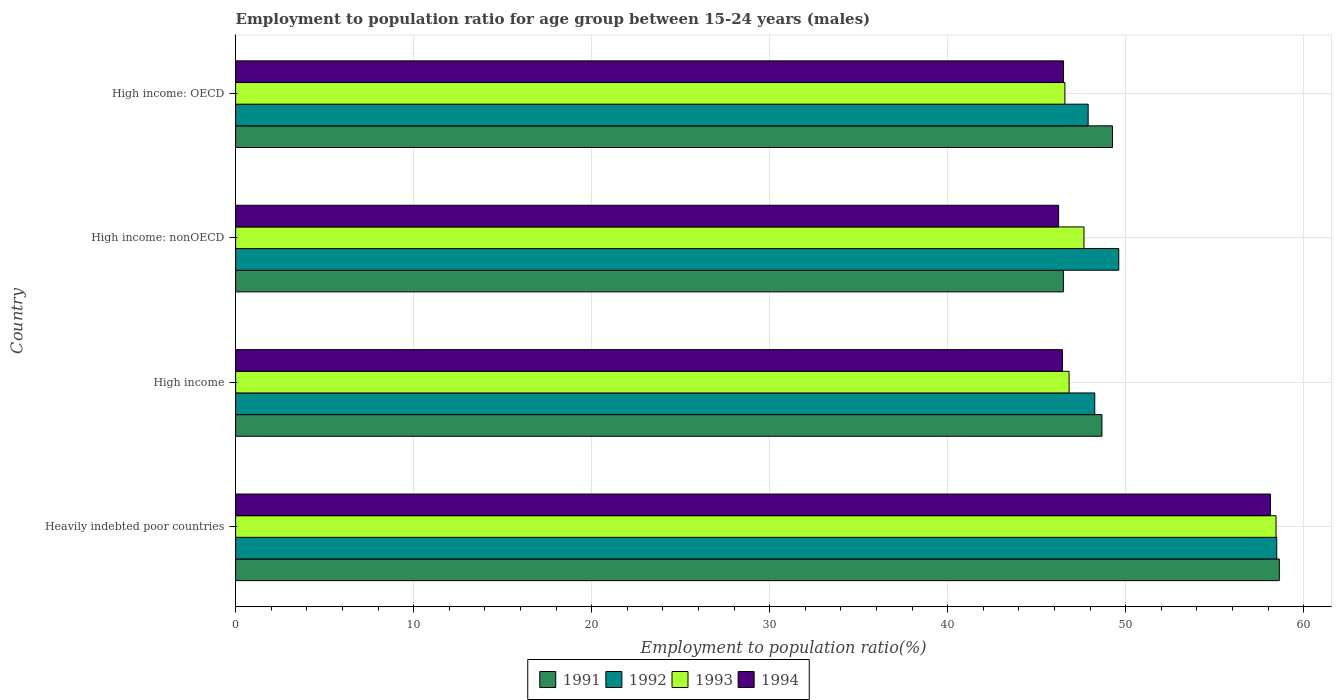How many groups of bars are there?
Keep it short and to the point. 4. Are the number of bars per tick equal to the number of legend labels?
Your answer should be very brief. Yes. Are the number of bars on each tick of the Y-axis equal?
Offer a very short reply. Yes. How many bars are there on the 2nd tick from the top?
Provide a short and direct response. 4. How many bars are there on the 2nd tick from the bottom?
Make the answer very short. 4. What is the label of the 2nd group of bars from the top?
Offer a very short reply. High income: nonOECD. In how many cases, is the number of bars for a given country not equal to the number of legend labels?
Provide a short and direct response. 0. What is the employment to population ratio in 1994 in High income: nonOECD?
Provide a succinct answer. 46.23. Across all countries, what is the maximum employment to population ratio in 1994?
Give a very brief answer. 58.13. Across all countries, what is the minimum employment to population ratio in 1994?
Your answer should be compact. 46.23. In which country was the employment to population ratio in 1994 maximum?
Your response must be concise. Heavily indebted poor countries. In which country was the employment to population ratio in 1992 minimum?
Keep it short and to the point. High income: OECD. What is the total employment to population ratio in 1991 in the graph?
Provide a short and direct response. 203.04. What is the difference between the employment to population ratio in 1992 in Heavily indebted poor countries and that in High income: nonOECD?
Your answer should be very brief. 8.87. What is the difference between the employment to population ratio in 1992 in Heavily indebted poor countries and the employment to population ratio in 1991 in High income: OECD?
Your response must be concise. 9.23. What is the average employment to population ratio in 1992 per country?
Give a very brief answer. 51.06. What is the difference between the employment to population ratio in 1994 and employment to population ratio in 1991 in High income?
Your answer should be compact. -2.22. What is the ratio of the employment to population ratio in 1994 in Heavily indebted poor countries to that in High income?
Your answer should be compact. 1.25. Is the employment to population ratio in 1992 in Heavily indebted poor countries less than that in High income: nonOECD?
Make the answer very short. No. Is the difference between the employment to population ratio in 1994 in Heavily indebted poor countries and High income: nonOECD greater than the difference between the employment to population ratio in 1991 in Heavily indebted poor countries and High income: nonOECD?
Keep it short and to the point. No. What is the difference between the highest and the second highest employment to population ratio in 1993?
Your answer should be very brief. 10.79. What is the difference between the highest and the lowest employment to population ratio in 1994?
Your answer should be compact. 11.9. In how many countries, is the employment to population ratio in 1992 greater than the average employment to population ratio in 1992 taken over all countries?
Ensure brevity in your answer.  1. Is it the case that in every country, the sum of the employment to population ratio in 1991 and employment to population ratio in 1993 is greater than the sum of employment to population ratio in 1994 and employment to population ratio in 1992?
Offer a terse response. No. What does the 4th bar from the bottom in High income: OECD represents?
Your answer should be very brief. 1994. How many bars are there?
Make the answer very short. 16. How many countries are there in the graph?
Offer a terse response. 4. What is the difference between two consecutive major ticks on the X-axis?
Give a very brief answer. 10. Are the values on the major ticks of X-axis written in scientific E-notation?
Offer a terse response. No. Does the graph contain any zero values?
Keep it short and to the point. No. Where does the legend appear in the graph?
Offer a terse response. Bottom center. How many legend labels are there?
Your answer should be compact. 4. What is the title of the graph?
Your answer should be compact. Employment to population ratio for age group between 15-24 years (males). Does "1964" appear as one of the legend labels in the graph?
Your response must be concise. No. What is the Employment to population ratio(%) in 1991 in Heavily indebted poor countries?
Your answer should be very brief. 58.63. What is the Employment to population ratio(%) of 1992 in Heavily indebted poor countries?
Provide a succinct answer. 58.48. What is the Employment to population ratio(%) of 1993 in Heavily indebted poor countries?
Provide a succinct answer. 58.44. What is the Employment to population ratio(%) of 1994 in Heavily indebted poor countries?
Your response must be concise. 58.13. What is the Employment to population ratio(%) in 1991 in High income?
Provide a succinct answer. 48.66. What is the Employment to population ratio(%) in 1992 in High income?
Offer a very short reply. 48.26. What is the Employment to population ratio(%) in 1993 in High income?
Your response must be concise. 46.82. What is the Employment to population ratio(%) in 1994 in High income?
Your answer should be very brief. 46.44. What is the Employment to population ratio(%) of 1991 in High income: nonOECD?
Make the answer very short. 46.5. What is the Employment to population ratio(%) of 1992 in High income: nonOECD?
Give a very brief answer. 49.61. What is the Employment to population ratio(%) in 1993 in High income: nonOECD?
Provide a succinct answer. 47.65. What is the Employment to population ratio(%) of 1994 in High income: nonOECD?
Make the answer very short. 46.23. What is the Employment to population ratio(%) in 1991 in High income: OECD?
Make the answer very short. 49.25. What is the Employment to population ratio(%) in 1992 in High income: OECD?
Provide a succinct answer. 47.89. What is the Employment to population ratio(%) in 1993 in High income: OECD?
Your answer should be compact. 46.58. What is the Employment to population ratio(%) in 1994 in High income: OECD?
Give a very brief answer. 46.5. Across all countries, what is the maximum Employment to population ratio(%) in 1991?
Keep it short and to the point. 58.63. Across all countries, what is the maximum Employment to population ratio(%) in 1992?
Provide a succinct answer. 58.48. Across all countries, what is the maximum Employment to population ratio(%) of 1993?
Your answer should be very brief. 58.44. Across all countries, what is the maximum Employment to population ratio(%) of 1994?
Your response must be concise. 58.13. Across all countries, what is the minimum Employment to population ratio(%) in 1991?
Your answer should be compact. 46.5. Across all countries, what is the minimum Employment to population ratio(%) in 1992?
Give a very brief answer. 47.89. Across all countries, what is the minimum Employment to population ratio(%) of 1993?
Provide a short and direct response. 46.58. Across all countries, what is the minimum Employment to population ratio(%) of 1994?
Your answer should be very brief. 46.23. What is the total Employment to population ratio(%) of 1991 in the graph?
Provide a short and direct response. 203.04. What is the total Employment to population ratio(%) in 1992 in the graph?
Offer a very short reply. 204.24. What is the total Employment to population ratio(%) of 1993 in the graph?
Provide a succinct answer. 199.5. What is the total Employment to population ratio(%) of 1994 in the graph?
Offer a very short reply. 197.3. What is the difference between the Employment to population ratio(%) of 1991 in Heavily indebted poor countries and that in High income?
Keep it short and to the point. 9.96. What is the difference between the Employment to population ratio(%) of 1992 in Heavily indebted poor countries and that in High income?
Your response must be concise. 10.22. What is the difference between the Employment to population ratio(%) of 1993 in Heavily indebted poor countries and that in High income?
Provide a succinct answer. 11.62. What is the difference between the Employment to population ratio(%) in 1994 in Heavily indebted poor countries and that in High income?
Provide a succinct answer. 11.69. What is the difference between the Employment to population ratio(%) of 1991 in Heavily indebted poor countries and that in High income: nonOECD?
Offer a terse response. 12.13. What is the difference between the Employment to population ratio(%) of 1992 in Heavily indebted poor countries and that in High income: nonOECD?
Offer a very short reply. 8.87. What is the difference between the Employment to population ratio(%) in 1993 in Heavily indebted poor countries and that in High income: nonOECD?
Offer a very short reply. 10.79. What is the difference between the Employment to population ratio(%) in 1994 in Heavily indebted poor countries and that in High income: nonOECD?
Offer a terse response. 11.9. What is the difference between the Employment to population ratio(%) of 1991 in Heavily indebted poor countries and that in High income: OECD?
Your answer should be compact. 9.37. What is the difference between the Employment to population ratio(%) of 1992 in Heavily indebted poor countries and that in High income: OECD?
Keep it short and to the point. 10.59. What is the difference between the Employment to population ratio(%) of 1993 in Heavily indebted poor countries and that in High income: OECD?
Provide a short and direct response. 11.86. What is the difference between the Employment to population ratio(%) of 1994 in Heavily indebted poor countries and that in High income: OECD?
Make the answer very short. 11.62. What is the difference between the Employment to population ratio(%) in 1991 in High income and that in High income: nonOECD?
Your answer should be very brief. 2.17. What is the difference between the Employment to population ratio(%) of 1992 in High income and that in High income: nonOECD?
Ensure brevity in your answer.  -1.35. What is the difference between the Employment to population ratio(%) in 1993 in High income and that in High income: nonOECD?
Offer a terse response. -0.84. What is the difference between the Employment to population ratio(%) of 1994 in High income and that in High income: nonOECD?
Provide a short and direct response. 0.21. What is the difference between the Employment to population ratio(%) of 1991 in High income and that in High income: OECD?
Offer a very short reply. -0.59. What is the difference between the Employment to population ratio(%) in 1992 in High income and that in High income: OECD?
Your response must be concise. 0.37. What is the difference between the Employment to population ratio(%) of 1993 in High income and that in High income: OECD?
Ensure brevity in your answer.  0.23. What is the difference between the Employment to population ratio(%) in 1994 in High income and that in High income: OECD?
Your answer should be very brief. -0.06. What is the difference between the Employment to population ratio(%) in 1991 in High income: nonOECD and that in High income: OECD?
Keep it short and to the point. -2.76. What is the difference between the Employment to population ratio(%) in 1992 in High income: nonOECD and that in High income: OECD?
Provide a short and direct response. 1.72. What is the difference between the Employment to population ratio(%) of 1993 in High income: nonOECD and that in High income: OECD?
Make the answer very short. 1.07. What is the difference between the Employment to population ratio(%) in 1994 in High income: nonOECD and that in High income: OECD?
Your response must be concise. -0.27. What is the difference between the Employment to population ratio(%) in 1991 in Heavily indebted poor countries and the Employment to population ratio(%) in 1992 in High income?
Make the answer very short. 10.37. What is the difference between the Employment to population ratio(%) of 1991 in Heavily indebted poor countries and the Employment to population ratio(%) of 1993 in High income?
Ensure brevity in your answer.  11.81. What is the difference between the Employment to population ratio(%) of 1991 in Heavily indebted poor countries and the Employment to population ratio(%) of 1994 in High income?
Your answer should be compact. 12.18. What is the difference between the Employment to population ratio(%) in 1992 in Heavily indebted poor countries and the Employment to population ratio(%) in 1993 in High income?
Make the answer very short. 11.66. What is the difference between the Employment to population ratio(%) in 1992 in Heavily indebted poor countries and the Employment to population ratio(%) in 1994 in High income?
Your answer should be very brief. 12.04. What is the difference between the Employment to population ratio(%) in 1993 in Heavily indebted poor countries and the Employment to population ratio(%) in 1994 in High income?
Offer a very short reply. 12. What is the difference between the Employment to population ratio(%) of 1991 in Heavily indebted poor countries and the Employment to population ratio(%) of 1992 in High income: nonOECD?
Your response must be concise. 9.02. What is the difference between the Employment to population ratio(%) of 1991 in Heavily indebted poor countries and the Employment to population ratio(%) of 1993 in High income: nonOECD?
Provide a short and direct response. 10.97. What is the difference between the Employment to population ratio(%) of 1991 in Heavily indebted poor countries and the Employment to population ratio(%) of 1994 in High income: nonOECD?
Your answer should be compact. 12.4. What is the difference between the Employment to population ratio(%) in 1992 in Heavily indebted poor countries and the Employment to population ratio(%) in 1993 in High income: nonOECD?
Make the answer very short. 10.83. What is the difference between the Employment to population ratio(%) in 1992 in Heavily indebted poor countries and the Employment to population ratio(%) in 1994 in High income: nonOECD?
Offer a very short reply. 12.25. What is the difference between the Employment to population ratio(%) in 1993 in Heavily indebted poor countries and the Employment to population ratio(%) in 1994 in High income: nonOECD?
Provide a short and direct response. 12.21. What is the difference between the Employment to population ratio(%) in 1991 in Heavily indebted poor countries and the Employment to population ratio(%) in 1992 in High income: OECD?
Make the answer very short. 10.74. What is the difference between the Employment to population ratio(%) in 1991 in Heavily indebted poor countries and the Employment to population ratio(%) in 1993 in High income: OECD?
Your answer should be very brief. 12.04. What is the difference between the Employment to population ratio(%) of 1991 in Heavily indebted poor countries and the Employment to population ratio(%) of 1994 in High income: OECD?
Provide a succinct answer. 12.12. What is the difference between the Employment to population ratio(%) in 1992 in Heavily indebted poor countries and the Employment to population ratio(%) in 1993 in High income: OECD?
Provide a short and direct response. 11.9. What is the difference between the Employment to population ratio(%) of 1992 in Heavily indebted poor countries and the Employment to population ratio(%) of 1994 in High income: OECD?
Your response must be concise. 11.98. What is the difference between the Employment to population ratio(%) of 1993 in Heavily indebted poor countries and the Employment to population ratio(%) of 1994 in High income: OECD?
Keep it short and to the point. 11.94. What is the difference between the Employment to population ratio(%) in 1991 in High income and the Employment to population ratio(%) in 1992 in High income: nonOECD?
Your answer should be compact. -0.94. What is the difference between the Employment to population ratio(%) of 1991 in High income and the Employment to population ratio(%) of 1993 in High income: nonOECD?
Make the answer very short. 1.01. What is the difference between the Employment to population ratio(%) in 1991 in High income and the Employment to population ratio(%) in 1994 in High income: nonOECD?
Provide a succinct answer. 2.43. What is the difference between the Employment to population ratio(%) of 1992 in High income and the Employment to population ratio(%) of 1993 in High income: nonOECD?
Provide a short and direct response. 0.61. What is the difference between the Employment to population ratio(%) of 1992 in High income and the Employment to population ratio(%) of 1994 in High income: nonOECD?
Ensure brevity in your answer.  2.03. What is the difference between the Employment to population ratio(%) in 1993 in High income and the Employment to population ratio(%) in 1994 in High income: nonOECD?
Your answer should be compact. 0.59. What is the difference between the Employment to population ratio(%) in 1991 in High income and the Employment to population ratio(%) in 1992 in High income: OECD?
Keep it short and to the point. 0.78. What is the difference between the Employment to population ratio(%) in 1991 in High income and the Employment to population ratio(%) in 1993 in High income: OECD?
Provide a short and direct response. 2.08. What is the difference between the Employment to population ratio(%) in 1991 in High income and the Employment to population ratio(%) in 1994 in High income: OECD?
Provide a succinct answer. 2.16. What is the difference between the Employment to population ratio(%) in 1992 in High income and the Employment to population ratio(%) in 1993 in High income: OECD?
Make the answer very short. 1.68. What is the difference between the Employment to population ratio(%) in 1992 in High income and the Employment to population ratio(%) in 1994 in High income: OECD?
Your answer should be compact. 1.76. What is the difference between the Employment to population ratio(%) in 1993 in High income and the Employment to population ratio(%) in 1994 in High income: OECD?
Provide a succinct answer. 0.31. What is the difference between the Employment to population ratio(%) of 1991 in High income: nonOECD and the Employment to population ratio(%) of 1992 in High income: OECD?
Your response must be concise. -1.39. What is the difference between the Employment to population ratio(%) of 1991 in High income: nonOECD and the Employment to population ratio(%) of 1993 in High income: OECD?
Make the answer very short. -0.09. What is the difference between the Employment to population ratio(%) of 1991 in High income: nonOECD and the Employment to population ratio(%) of 1994 in High income: OECD?
Your answer should be very brief. -0.01. What is the difference between the Employment to population ratio(%) in 1992 in High income: nonOECD and the Employment to population ratio(%) in 1993 in High income: OECD?
Provide a short and direct response. 3.03. What is the difference between the Employment to population ratio(%) of 1992 in High income: nonOECD and the Employment to population ratio(%) of 1994 in High income: OECD?
Your answer should be very brief. 3.1. What is the difference between the Employment to population ratio(%) in 1993 in High income: nonOECD and the Employment to population ratio(%) in 1994 in High income: OECD?
Offer a very short reply. 1.15. What is the average Employment to population ratio(%) of 1991 per country?
Keep it short and to the point. 50.76. What is the average Employment to population ratio(%) in 1992 per country?
Offer a very short reply. 51.06. What is the average Employment to population ratio(%) in 1993 per country?
Your response must be concise. 49.87. What is the average Employment to population ratio(%) of 1994 per country?
Make the answer very short. 49.33. What is the difference between the Employment to population ratio(%) in 1991 and Employment to population ratio(%) in 1992 in Heavily indebted poor countries?
Your response must be concise. 0.14. What is the difference between the Employment to population ratio(%) in 1991 and Employment to population ratio(%) in 1993 in Heavily indebted poor countries?
Make the answer very short. 0.18. What is the difference between the Employment to population ratio(%) in 1991 and Employment to population ratio(%) in 1994 in Heavily indebted poor countries?
Offer a very short reply. 0.5. What is the difference between the Employment to population ratio(%) in 1992 and Employment to population ratio(%) in 1993 in Heavily indebted poor countries?
Keep it short and to the point. 0.04. What is the difference between the Employment to population ratio(%) in 1992 and Employment to population ratio(%) in 1994 in Heavily indebted poor countries?
Keep it short and to the point. 0.35. What is the difference between the Employment to population ratio(%) in 1993 and Employment to population ratio(%) in 1994 in Heavily indebted poor countries?
Your response must be concise. 0.31. What is the difference between the Employment to population ratio(%) of 1991 and Employment to population ratio(%) of 1992 in High income?
Your answer should be compact. 0.4. What is the difference between the Employment to population ratio(%) in 1991 and Employment to population ratio(%) in 1993 in High income?
Make the answer very short. 1.85. What is the difference between the Employment to population ratio(%) in 1991 and Employment to population ratio(%) in 1994 in High income?
Your response must be concise. 2.22. What is the difference between the Employment to population ratio(%) of 1992 and Employment to population ratio(%) of 1993 in High income?
Make the answer very short. 1.44. What is the difference between the Employment to population ratio(%) of 1992 and Employment to population ratio(%) of 1994 in High income?
Ensure brevity in your answer.  1.82. What is the difference between the Employment to population ratio(%) in 1993 and Employment to population ratio(%) in 1994 in High income?
Your answer should be very brief. 0.38. What is the difference between the Employment to population ratio(%) of 1991 and Employment to population ratio(%) of 1992 in High income: nonOECD?
Your answer should be very brief. -3.11. What is the difference between the Employment to population ratio(%) of 1991 and Employment to population ratio(%) of 1993 in High income: nonOECD?
Ensure brevity in your answer.  -1.16. What is the difference between the Employment to population ratio(%) in 1991 and Employment to population ratio(%) in 1994 in High income: nonOECD?
Provide a succinct answer. 0.27. What is the difference between the Employment to population ratio(%) in 1992 and Employment to population ratio(%) in 1993 in High income: nonOECD?
Give a very brief answer. 1.95. What is the difference between the Employment to population ratio(%) of 1992 and Employment to population ratio(%) of 1994 in High income: nonOECD?
Give a very brief answer. 3.38. What is the difference between the Employment to population ratio(%) of 1993 and Employment to population ratio(%) of 1994 in High income: nonOECD?
Offer a terse response. 1.42. What is the difference between the Employment to population ratio(%) in 1991 and Employment to population ratio(%) in 1992 in High income: OECD?
Offer a very short reply. 1.37. What is the difference between the Employment to population ratio(%) in 1991 and Employment to population ratio(%) in 1993 in High income: OECD?
Offer a terse response. 2.67. What is the difference between the Employment to population ratio(%) of 1991 and Employment to population ratio(%) of 1994 in High income: OECD?
Provide a succinct answer. 2.75. What is the difference between the Employment to population ratio(%) of 1992 and Employment to population ratio(%) of 1993 in High income: OECD?
Provide a short and direct response. 1.31. What is the difference between the Employment to population ratio(%) in 1992 and Employment to population ratio(%) in 1994 in High income: OECD?
Your answer should be very brief. 1.38. What is the difference between the Employment to population ratio(%) of 1993 and Employment to population ratio(%) of 1994 in High income: OECD?
Provide a succinct answer. 0.08. What is the ratio of the Employment to population ratio(%) of 1991 in Heavily indebted poor countries to that in High income?
Provide a short and direct response. 1.2. What is the ratio of the Employment to population ratio(%) of 1992 in Heavily indebted poor countries to that in High income?
Your response must be concise. 1.21. What is the ratio of the Employment to population ratio(%) of 1993 in Heavily indebted poor countries to that in High income?
Make the answer very short. 1.25. What is the ratio of the Employment to population ratio(%) in 1994 in Heavily indebted poor countries to that in High income?
Offer a very short reply. 1.25. What is the ratio of the Employment to population ratio(%) in 1991 in Heavily indebted poor countries to that in High income: nonOECD?
Your answer should be compact. 1.26. What is the ratio of the Employment to population ratio(%) in 1992 in Heavily indebted poor countries to that in High income: nonOECD?
Offer a terse response. 1.18. What is the ratio of the Employment to population ratio(%) in 1993 in Heavily indebted poor countries to that in High income: nonOECD?
Offer a very short reply. 1.23. What is the ratio of the Employment to population ratio(%) of 1994 in Heavily indebted poor countries to that in High income: nonOECD?
Your response must be concise. 1.26. What is the ratio of the Employment to population ratio(%) of 1991 in Heavily indebted poor countries to that in High income: OECD?
Make the answer very short. 1.19. What is the ratio of the Employment to population ratio(%) in 1992 in Heavily indebted poor countries to that in High income: OECD?
Ensure brevity in your answer.  1.22. What is the ratio of the Employment to population ratio(%) of 1993 in Heavily indebted poor countries to that in High income: OECD?
Your answer should be compact. 1.25. What is the ratio of the Employment to population ratio(%) of 1991 in High income to that in High income: nonOECD?
Offer a terse response. 1.05. What is the ratio of the Employment to population ratio(%) of 1992 in High income to that in High income: nonOECD?
Your answer should be very brief. 0.97. What is the ratio of the Employment to population ratio(%) in 1993 in High income to that in High income: nonOECD?
Keep it short and to the point. 0.98. What is the ratio of the Employment to population ratio(%) of 1992 in High income to that in High income: OECD?
Your response must be concise. 1.01. What is the ratio of the Employment to population ratio(%) of 1994 in High income to that in High income: OECD?
Offer a very short reply. 1. What is the ratio of the Employment to population ratio(%) of 1991 in High income: nonOECD to that in High income: OECD?
Your response must be concise. 0.94. What is the ratio of the Employment to population ratio(%) of 1992 in High income: nonOECD to that in High income: OECD?
Make the answer very short. 1.04. What is the difference between the highest and the second highest Employment to population ratio(%) of 1991?
Your response must be concise. 9.37. What is the difference between the highest and the second highest Employment to population ratio(%) of 1992?
Ensure brevity in your answer.  8.87. What is the difference between the highest and the second highest Employment to population ratio(%) of 1993?
Offer a terse response. 10.79. What is the difference between the highest and the second highest Employment to population ratio(%) in 1994?
Ensure brevity in your answer.  11.62. What is the difference between the highest and the lowest Employment to population ratio(%) in 1991?
Ensure brevity in your answer.  12.13. What is the difference between the highest and the lowest Employment to population ratio(%) of 1992?
Provide a short and direct response. 10.59. What is the difference between the highest and the lowest Employment to population ratio(%) in 1993?
Your answer should be compact. 11.86. What is the difference between the highest and the lowest Employment to population ratio(%) of 1994?
Your answer should be compact. 11.9. 